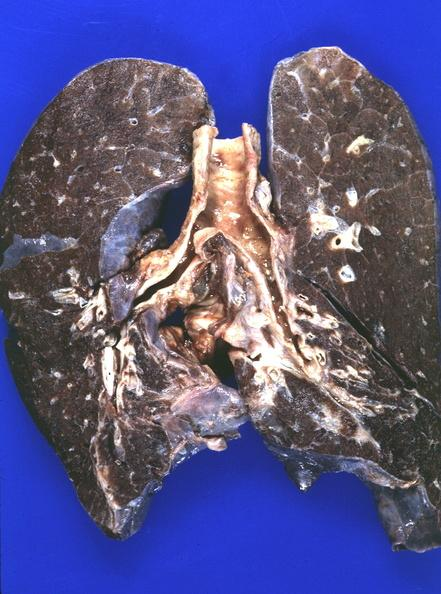what does this image show?
Answer the question using a single word or phrase. Lung 